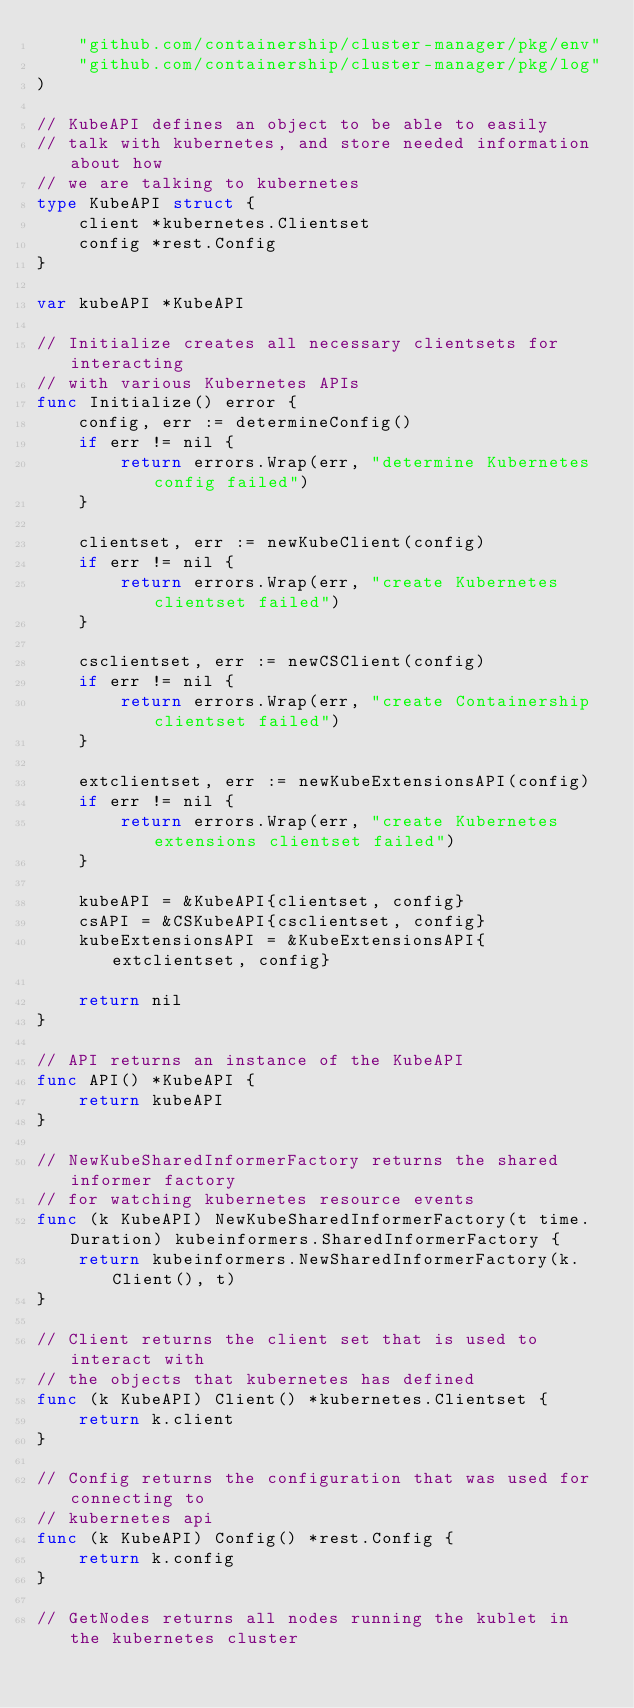<code> <loc_0><loc_0><loc_500><loc_500><_Go_>	"github.com/containership/cluster-manager/pkg/env"
	"github.com/containership/cluster-manager/pkg/log"
)

// KubeAPI defines an object to be able to easily
// talk with kubernetes, and store needed information about how
// we are talking to kubernetes
type KubeAPI struct {
	client *kubernetes.Clientset
	config *rest.Config
}

var kubeAPI *KubeAPI

// Initialize creates all necessary clientsets for interacting
// with various Kubernetes APIs
func Initialize() error {
	config, err := determineConfig()
	if err != nil {
		return errors.Wrap(err, "determine Kubernetes config failed")
	}

	clientset, err := newKubeClient(config)
	if err != nil {
		return errors.Wrap(err, "create Kubernetes clientset failed")
	}

	csclientset, err := newCSClient(config)
	if err != nil {
		return errors.Wrap(err, "create Containership clientset failed")
	}

	extclientset, err := newKubeExtensionsAPI(config)
	if err != nil {
		return errors.Wrap(err, "create Kubernetes extensions clientset failed")
	}

	kubeAPI = &KubeAPI{clientset, config}
	csAPI = &CSKubeAPI{csclientset, config}
	kubeExtensionsAPI = &KubeExtensionsAPI{extclientset, config}

	return nil
}

// API returns an instance of the KubeAPI
func API() *KubeAPI {
	return kubeAPI
}

// NewKubeSharedInformerFactory returns the shared informer factory
// for watching kubernetes resource events
func (k KubeAPI) NewKubeSharedInformerFactory(t time.Duration) kubeinformers.SharedInformerFactory {
	return kubeinformers.NewSharedInformerFactory(k.Client(), t)
}

// Client returns the client set that is used to interact with
// the objects that kubernetes has defined
func (k KubeAPI) Client() *kubernetes.Clientset {
	return k.client
}

// Config returns the configuration that was used for connecting to
// kubernetes api
func (k KubeAPI) Config() *rest.Config {
	return k.config
}

// GetNodes returns all nodes running the kublet in the kubernetes cluster</code> 